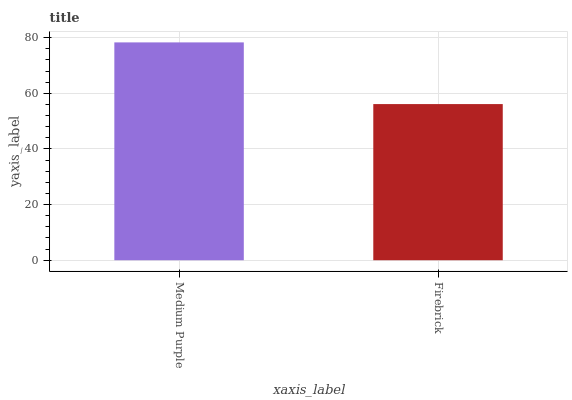Is Firebrick the minimum?
Answer yes or no. Yes. Is Medium Purple the maximum?
Answer yes or no. Yes. Is Firebrick the maximum?
Answer yes or no. No. Is Medium Purple greater than Firebrick?
Answer yes or no. Yes. Is Firebrick less than Medium Purple?
Answer yes or no. Yes. Is Firebrick greater than Medium Purple?
Answer yes or no. No. Is Medium Purple less than Firebrick?
Answer yes or no. No. Is Medium Purple the high median?
Answer yes or no. Yes. Is Firebrick the low median?
Answer yes or no. Yes. Is Firebrick the high median?
Answer yes or no. No. Is Medium Purple the low median?
Answer yes or no. No. 